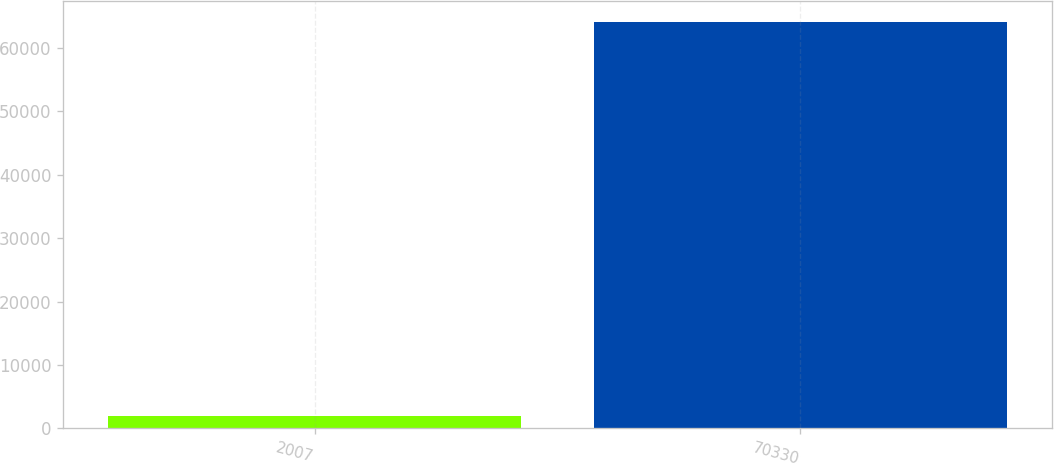Convert chart to OTSL. <chart><loc_0><loc_0><loc_500><loc_500><bar_chart><fcel>2007<fcel>70330<nl><fcel>2006<fcel>64099<nl></chart> 